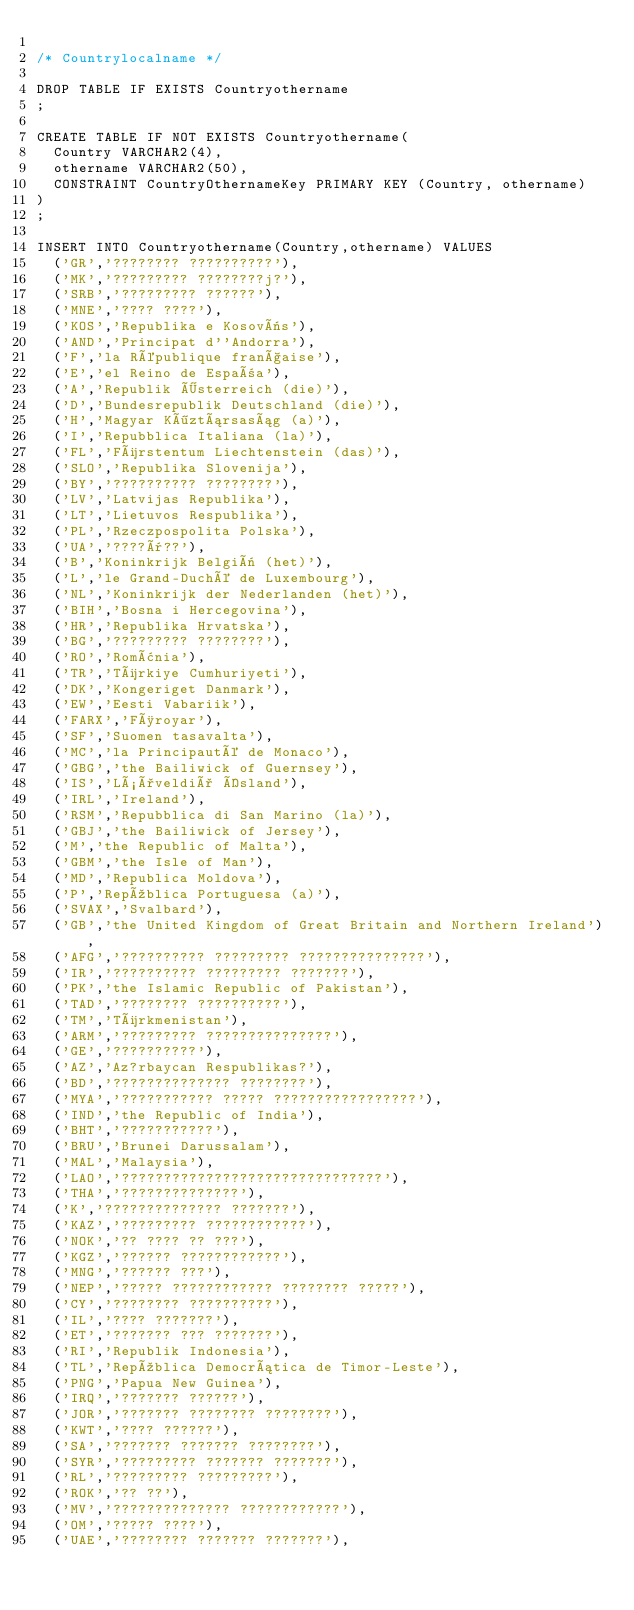Convert code to text. <code><loc_0><loc_0><loc_500><loc_500><_SQL_>
/* Countrylocalname */

DROP TABLE IF EXISTS Countryothername
;

CREATE TABLE IF NOT EXISTS Countryothername(
	Country VARCHAR2(4),
	othername VARCHAR2(50),
	CONSTRAINT CountryOthernameKey PRIMARY KEY (Country, othername)
)
;

INSERT INTO Countryothername(Country,othername) VALUES  
	('GR','???????? ??????????'),
	('MK','????????? ????????j?'),
	('SRB','????????? ??????'),
	('MNE','???? ????'),
	('KOS','Republika e Kosovës'),
	('AND','Principat d''Andorra'),
	('F','la République française'),
	('E','el Reino de España'),
	('A','Republik Österreich (die)'),
	('D','Bundesrepublik Deutschland (die)'),
	('H','Magyar Köztársaság (a)'),
	('I','Repubblica Italiana (la)'),
	('FL','Fürstentum Liechtenstein (das)'),
	('SLO','Republika Slovenija'),
	('BY','?????????? ????????'),
	('LV','Latvijas Republika'),
	('LT','Lietuvos Respublika'),
	('PL','Rzeczpospolita Polska'),
	('UA','????ï??'),
	('B','Koninkrijk België (het)'),
	('L','le Grand-Duché de Luxembourg'),
	('NL','Koninkrijk der Nederlanden (het)'),
	('BIH','Bosna i Hercegovina'),
	('HR','Republika Hrvatska'),
	('BG','????????? ????????'),
	('RO','România'),
	('TR','Türkiye Cumhuriyeti'),
	('DK','Kongeriget Danmark'),
	('EW','Eesti Vabariik'),
	('FARX','Føroyar'),
	('SF','Suomen tasavalta'),
	('MC','la Principauté de Monaco'),
	('GBG','the Bailiwick of Guernsey'),
	('IS','Lýðveldið Ísland'),
	('IRL','Ireland'),
	('RSM','Repubblica di San Marino (la)'),
	('GBJ','the Bailiwick of Jersey'),
	('M','the Republic of Malta'),
	('GBM','the Isle of Man'),
	('MD','Republica Moldova'),
	('P','República Portuguesa (a)'),
	('SVAX','Svalbard'),
	('GB','the United Kingdom of Great Britain and Northern Ireland'),
	('AFG','?????????? ????????? ???????????????'),
	('IR','?????????? ????????? ???????'),
	('PK','the Islamic Republic of Pakistan'),
	('TAD','???????? ??????????'),
	('TM','Türkmenistan'),
	('ARM','????????? ???????????????'),
	('GE','??????????'),
	('AZ','Az?rbaycan Respublikas?'),
	('BD','?????????????? ????????'),
	('MYA','??????????? ????? ?????????????????'),
	('IND','the Republic of India'),
	('BHT','???????????'),
	('BRU','Brunei Darussalam'),
	('MAL','Malaysia'),
	('LAO','???????????????????????????????'),
	('THA','??????????????'),
	('K','?????????????? ???????'),
	('KAZ','????????? ????????????'),
	('NOK','?? ???? ?? ???'),
	('KGZ','?????? ????????????'),
	('MNG','?????? ???'),
	('NEP','????? ???????????? ???????? ?????'),
	('CY','???????? ??????????'),
	('IL','???? ???????'),
	('ET','??????? ??? ???????'),
	('RI','Republik Indonesia'),
	('TL','República Democrática de Timor-Leste'),
	('PNG','Papua New Guinea'),
	('IRQ','??????? ??????'),
	('JOR','??????? ???????? ????????'),
	('KWT','???? ??????'),
	('SA','??????? ??????? ????????'),
	('SYR','????????? ??????? ???????'),
	('RL','????????? ?????????'),
	('ROK','?? ??'),
	('MV','?????????????? ????????????'),
	('OM','????? ????'),
	('UAE','???????? ??????? ???????'),</code> 